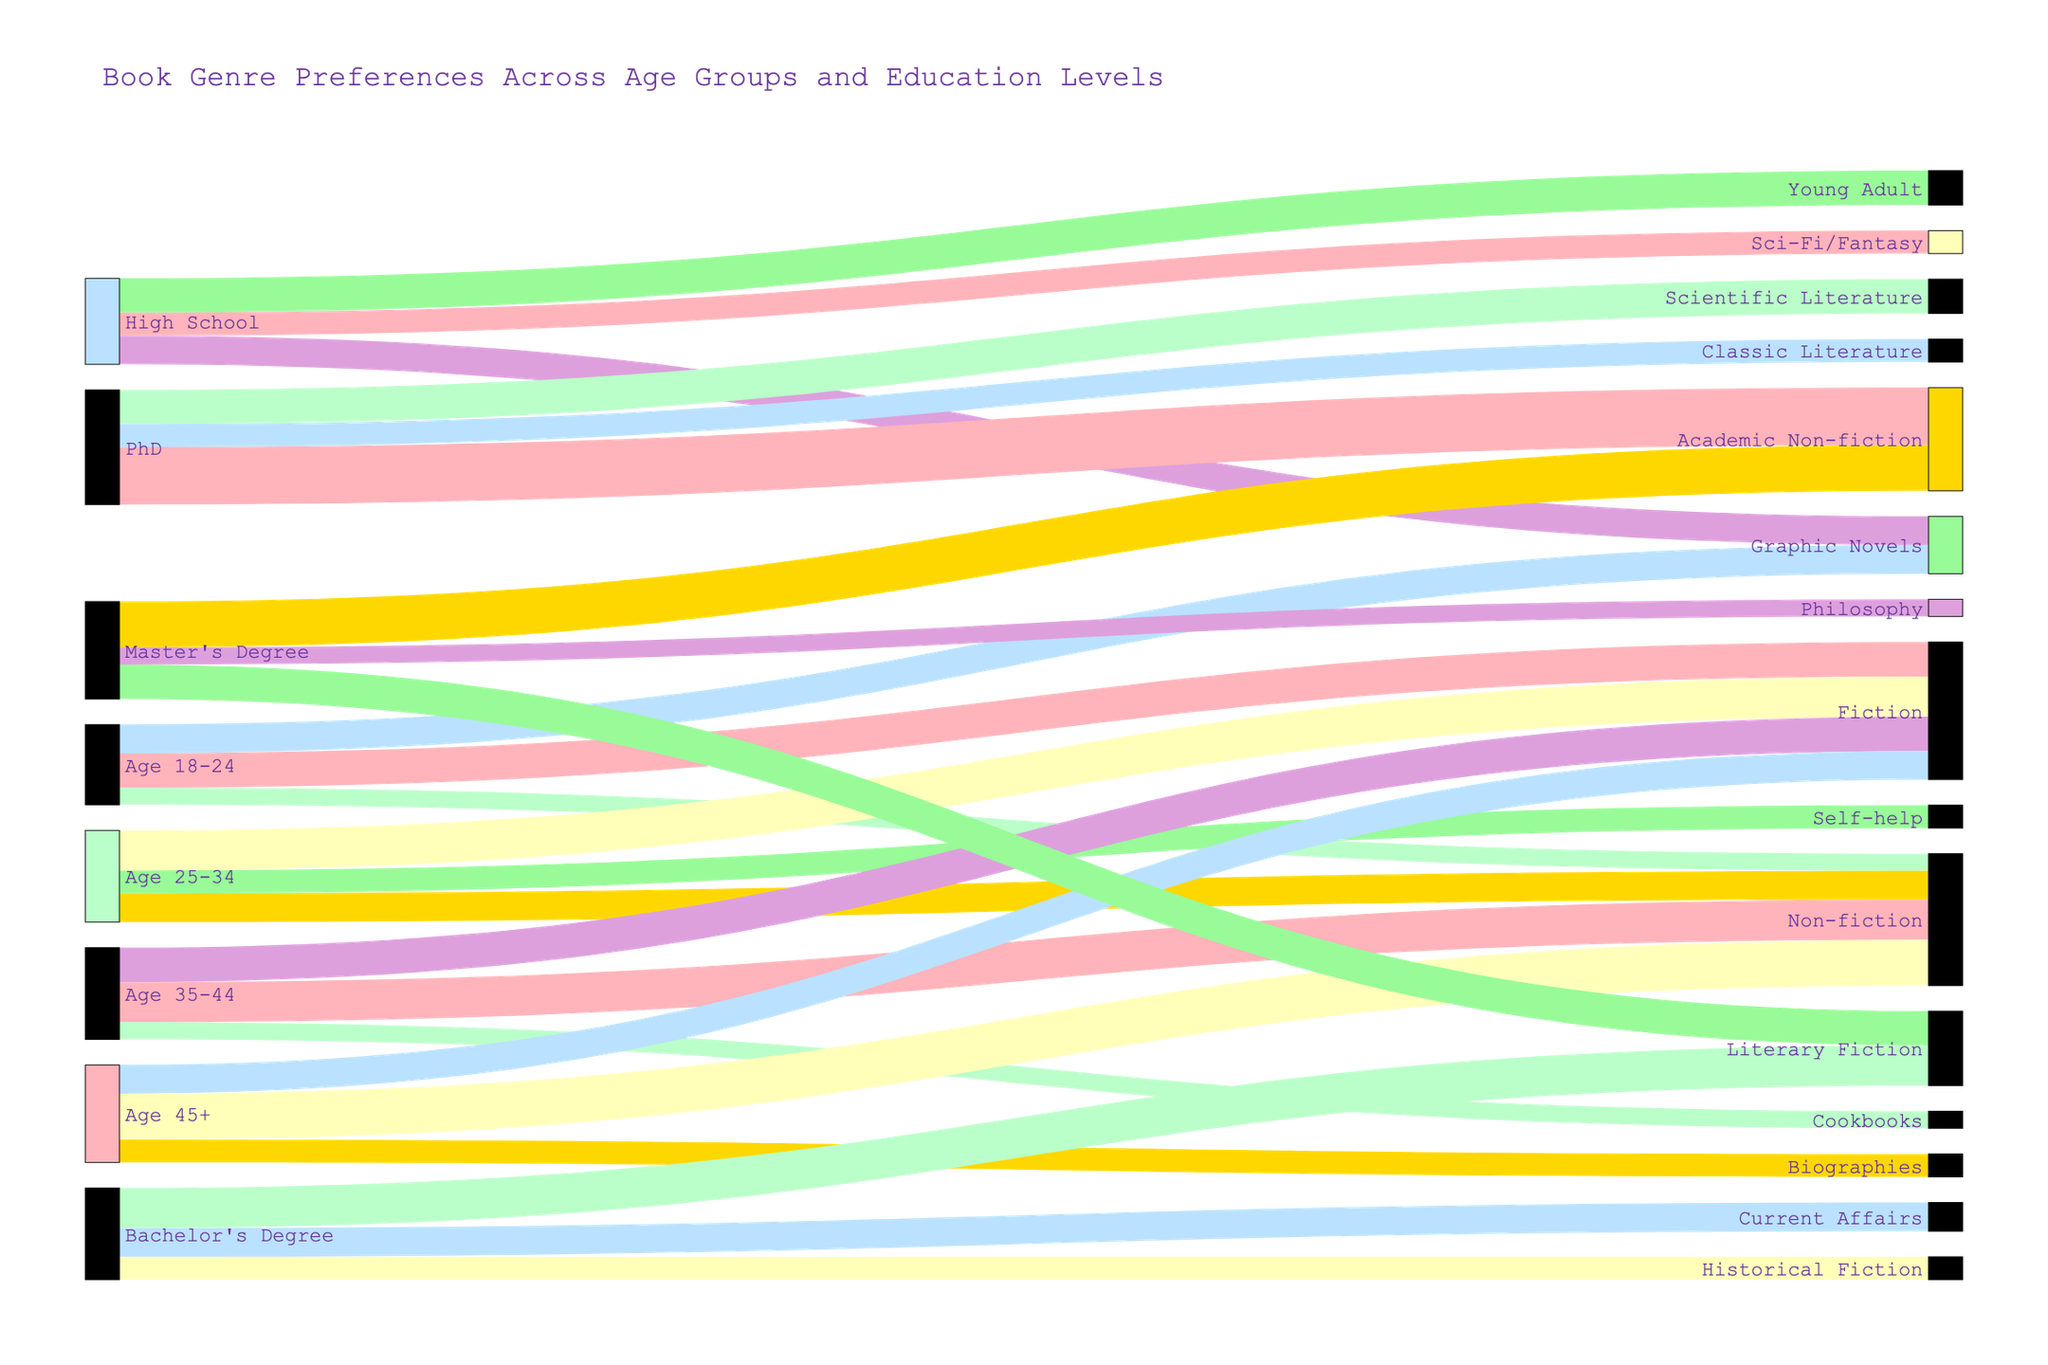What age group has the highest preference for Fiction? Look for the connections in the Sankey diagram originating from age groups to Fiction. Identify the age group with the largest flow/connection in terms of width.
Answer: Age 25-34 Which educational level shows the highest preference for Academic Non-fiction? Locate the flows/links between educational levels and genres, focusing on Academic Non-fiction. Identify the educational level with the largest flow.
Answer: PhD What is the total number of people who prefer Non-fiction across all age groups? Sum up the widths of all the flows/links that connect any age group to Non-fiction.
Answer: 115 (15 + 25 + 35 + 40) Which genre has the least preference among the age group 18-24? Examine the widths of the flows/links between the age group 18-24 and various genres. Identify the genre with the narrowest flow/connection.
Answer: Non-fiction Is the preference for Fiction higher in the age group 18-24 or age group 35-44? Compare the widths of the flows/links from age group 18-24 to Fiction and from 35-44 to Fiction. Determine which age group has the wider connection.
Answer: Age 25-34 How does the preference for Graphic Novels compare between High School education and age group 18-24? Compare the widths of the flows/links from High School to Graphic Novels and from age group 18-24 to Graphic Novels.
Answer: High School What is the overall preference for Literary Fiction across all educational levels? Sum the widths of all the connections from any educational level to Literary Fiction.
Answer: 65 (35 + 30) Which age group has the broadest range of genre preferences shown in the chart? Identify the age group that connects to the most diverse number of genres by counting the number of different links from each age group.
Answer: Age 25-34 